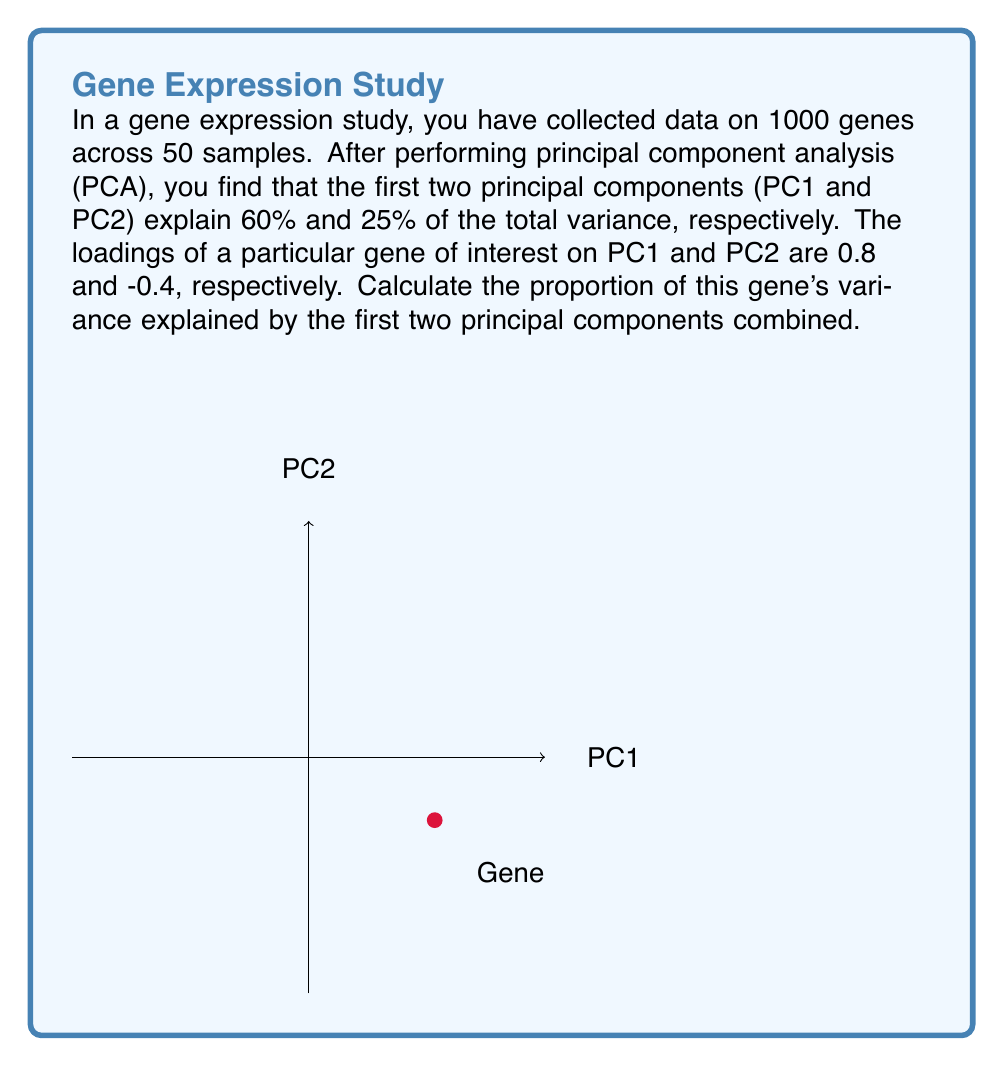Can you answer this question? To solve this problem, we'll follow these steps:

1) In PCA, the proportion of variance explained by each principal component is equal to its eigenvalue divided by the sum of all eigenvalues.

2) The loadings of a gene on the principal components represent the correlation between the gene and the principal components.

3) The proportion of a gene's variance explained by a principal component is equal to the square of its loading on that component.

4) To find the total proportion of variance explained by multiple principal components, we sum the squared loadings for those components.

5) In this case:
   - Loading on PC1 = 0.8
   - Loading on PC2 = -0.4

6) Calculate the squared loadings:
   $$PC1: 0.8^2 = 0.64$$
   $$PC2: (-0.4)^2 = 0.16$$

7) Sum the squared loadings:
   $$0.64 + 0.16 = 0.80$$

8) Therefore, the first two principal components explain 80% of this gene's variance.

9) We can verify this result:
   - PC1 explains 60% of total variance, and this gene has a loading of 0.8 on PC1
   - PC2 explains 25% of total variance, and this gene has a loading of -0.4 on PC2
   $$0.8^2 \times 60\% + (-0.4)^2 \times 25\% = 0.64 \times 0.60 + 0.16 \times 0.25 = 0.384 + 0.04 = 0.424$$
   
   This equals 42.4% of the total variance across all genes, which is consistent with our previous calculation of 80% of this specific gene's variance.
Answer: 80% 